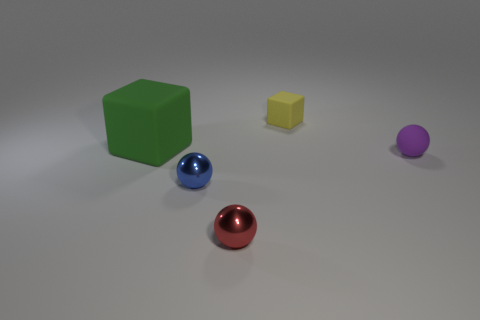Add 2 small blue metal cylinders. How many objects exist? 7 Subtract all balls. How many objects are left? 2 Subtract all big green things. Subtract all purple objects. How many objects are left? 3 Add 4 tiny purple spheres. How many tiny purple spheres are left? 5 Add 4 big purple matte balls. How many big purple matte balls exist? 4 Subtract 0 gray blocks. How many objects are left? 5 